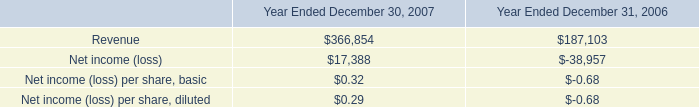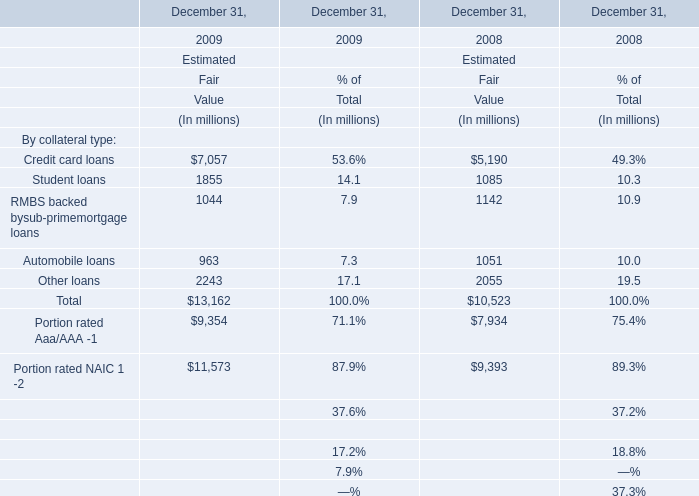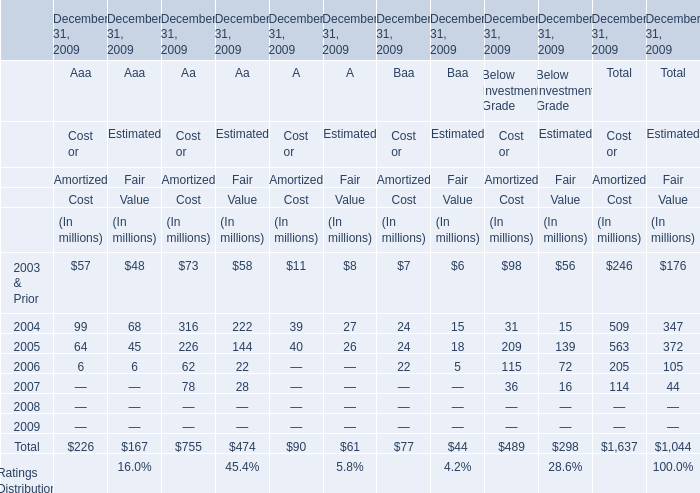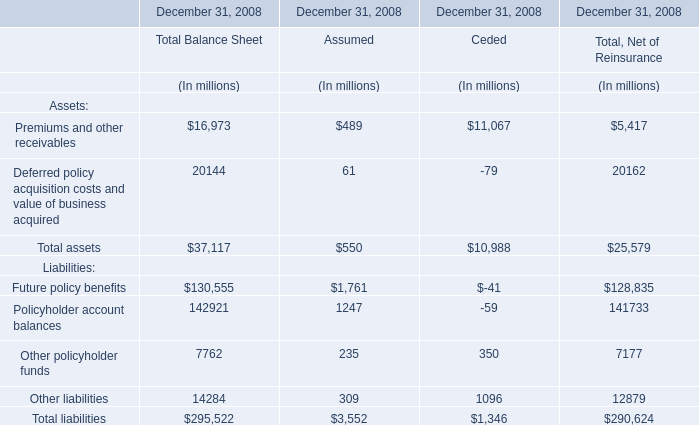what was the percentage change in revenue on a pro forma basis between 2006 and 2007? 
Computations: ((366854 - 187103) / 187103)
Answer: 0.96071. 